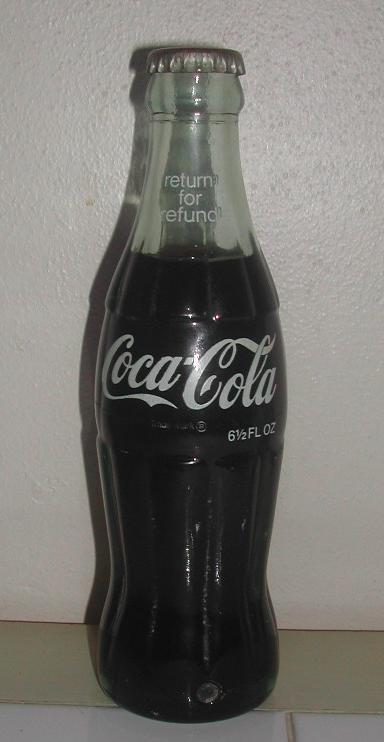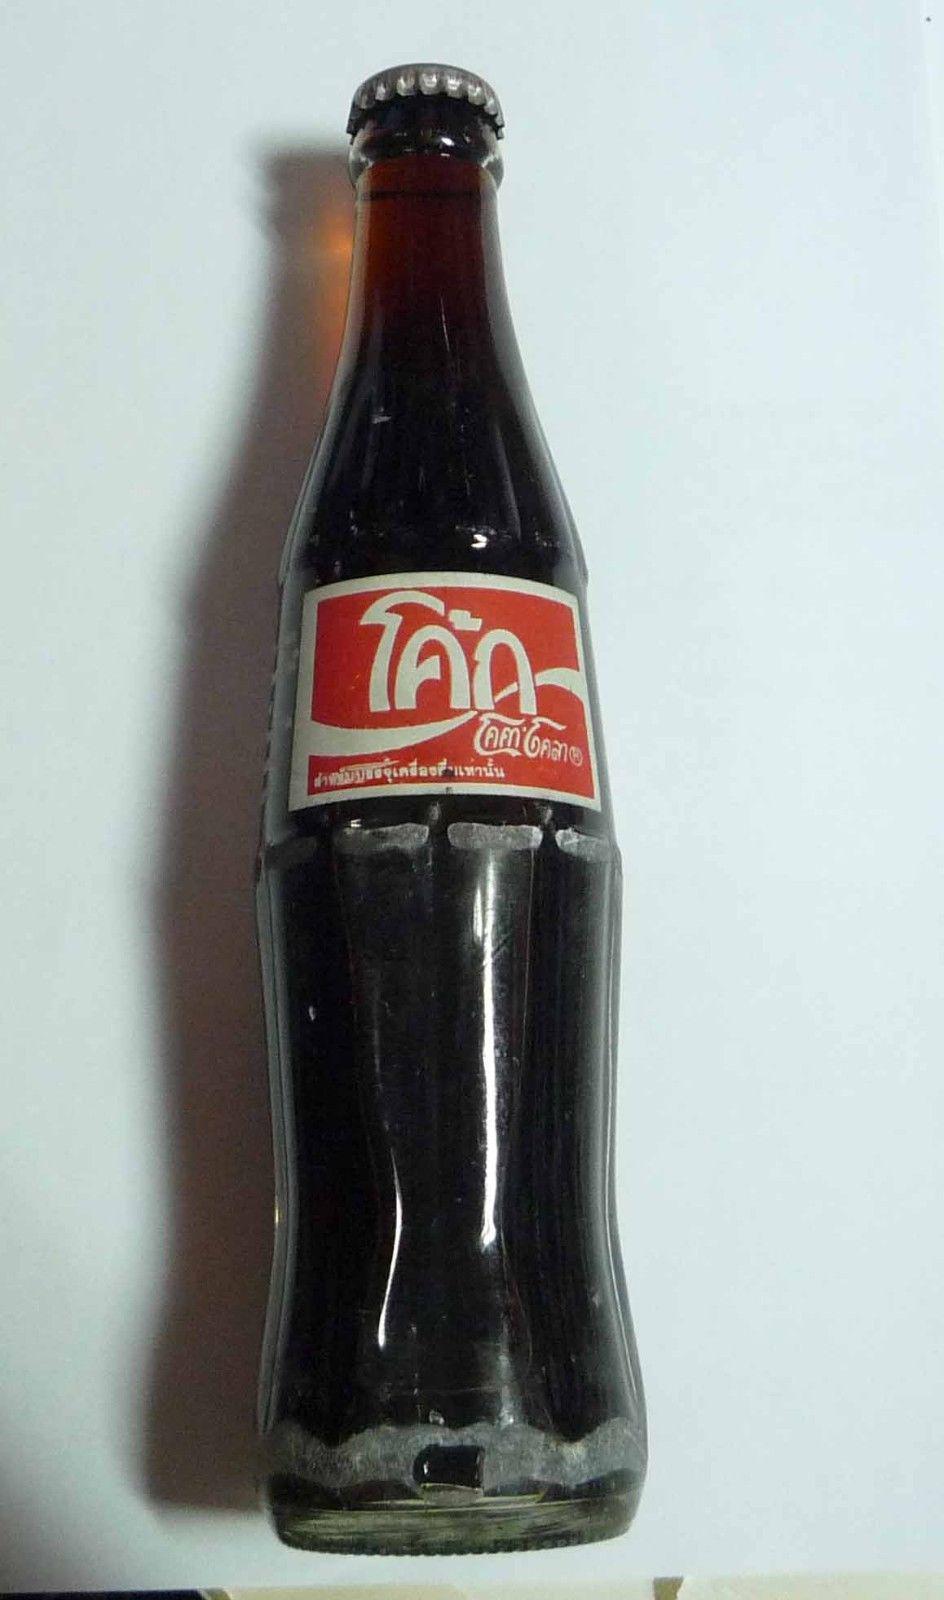The first image is the image on the left, the second image is the image on the right. Analyze the images presented: Is the assertion "At least one soda bottle is written in a foreign language." valid? Answer yes or no. Yes. The first image is the image on the left, the second image is the image on the right. Given the left and right images, does the statement "The bottle in the left image has a partly red label." hold true? Answer yes or no. No. 